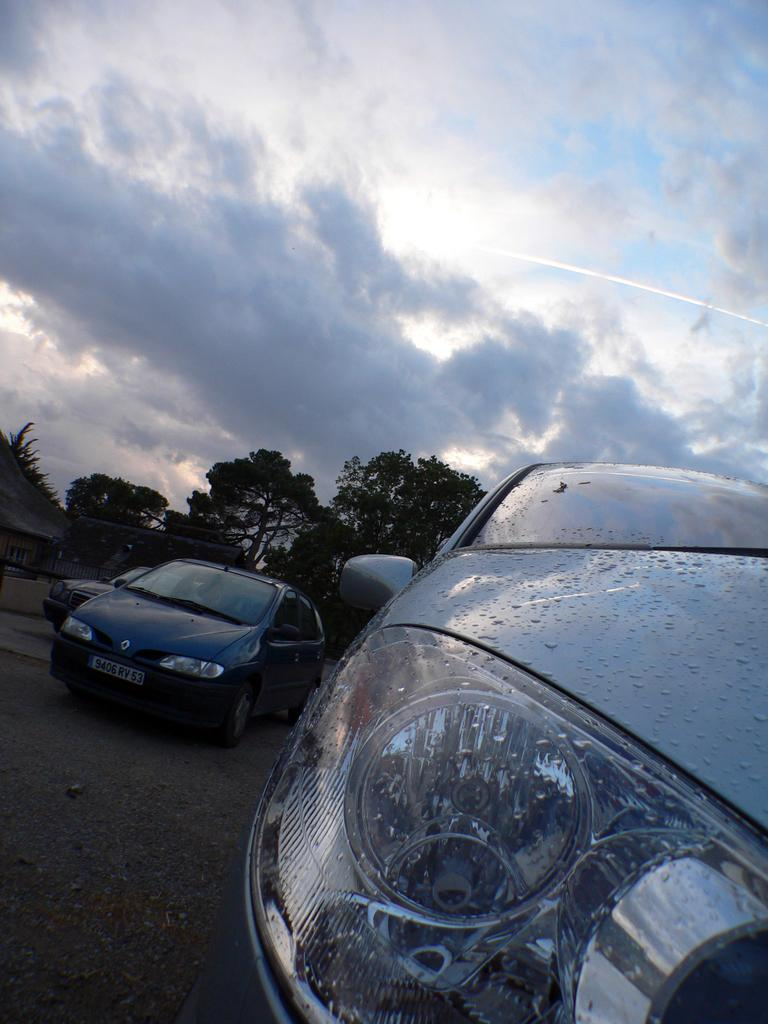Where was the image taken? The image was taken outside. What can be seen in the foreground of the image? There are cars and trees in the foreground of the image. What structure is visible in the left corner of the image? There is a house in the left corner of the image. What is visible in the background of the image? There is a sky visible in the background of the image. What advice does the grandfather give in the image? There is no grandfather present in the image, nor is there any advice being given. 